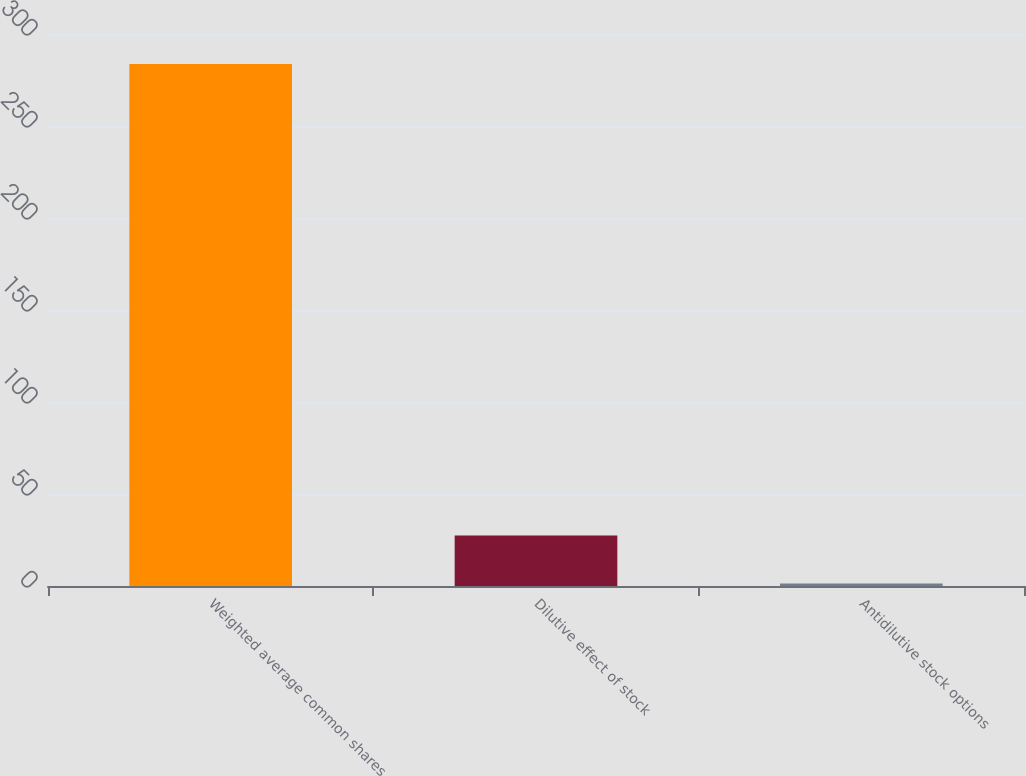<chart> <loc_0><loc_0><loc_500><loc_500><bar_chart><fcel>Weighted average common shares<fcel>Dilutive effect of stock<fcel>Antidilutive stock options<nl><fcel>283.67<fcel>27.47<fcel>1.4<nl></chart> 